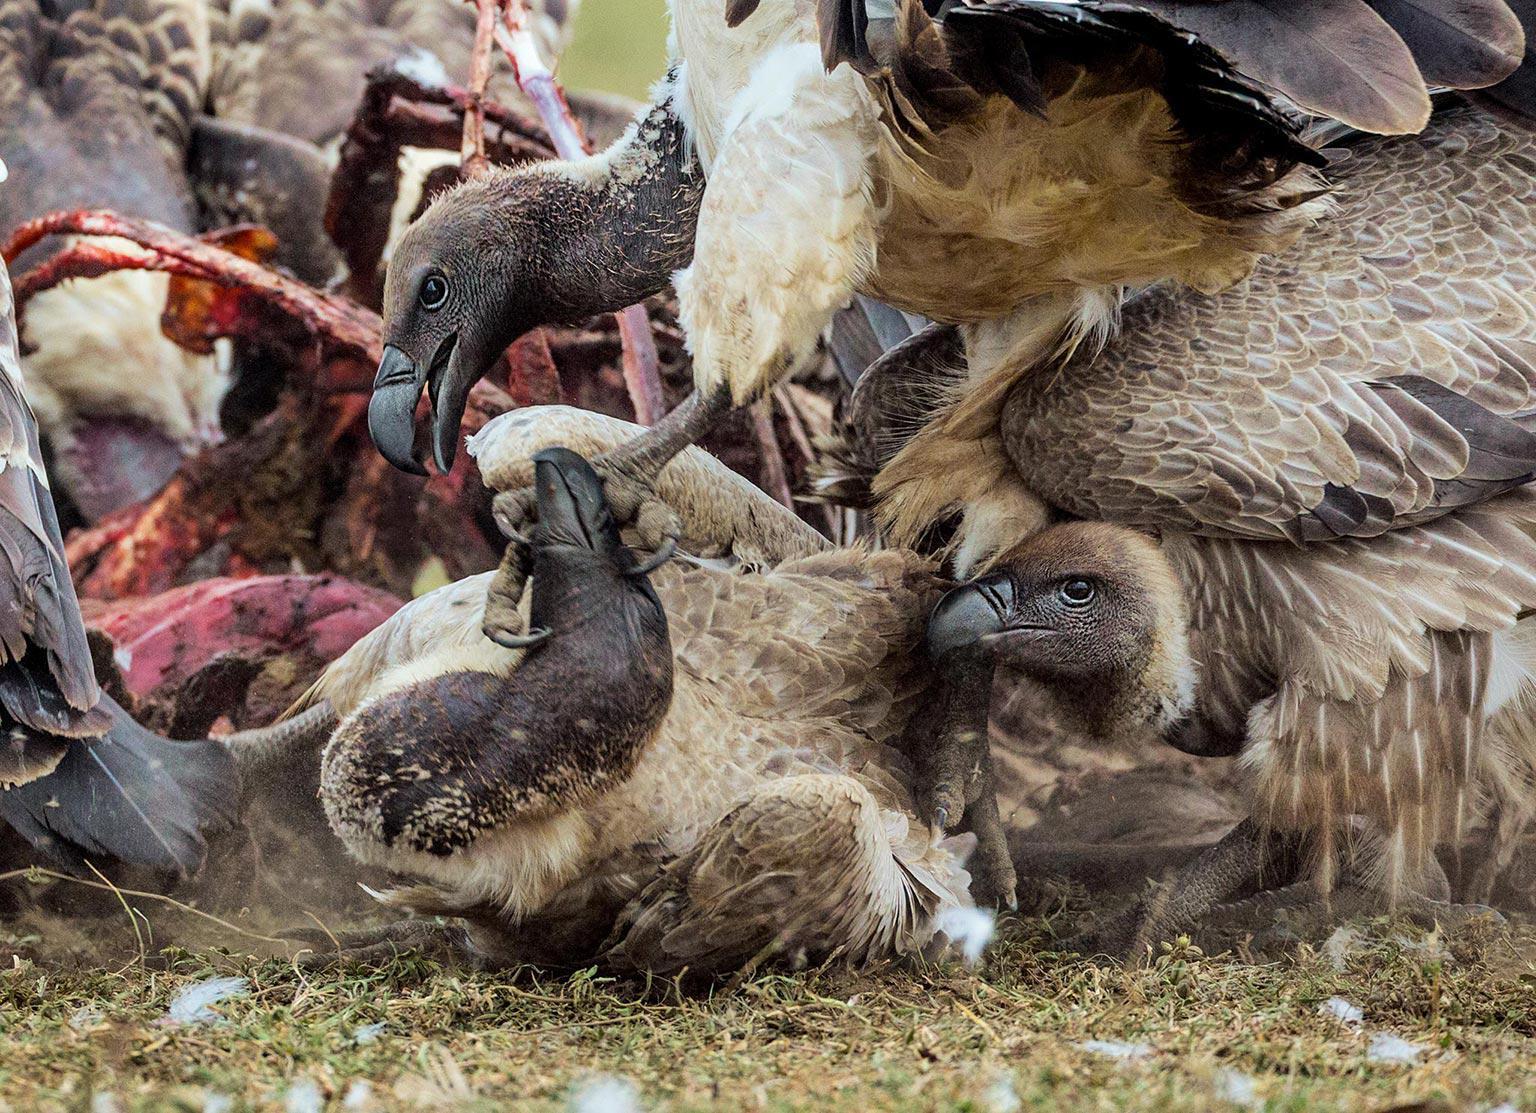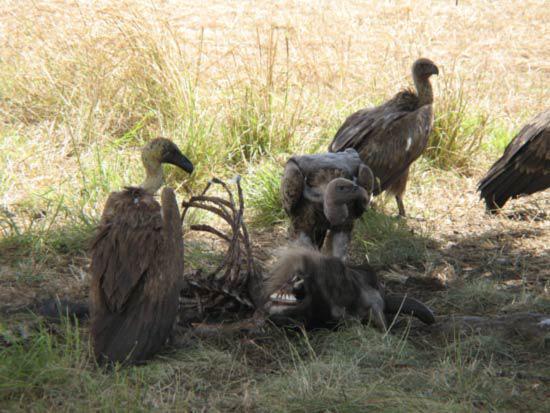The first image is the image on the left, the second image is the image on the right. For the images shown, is this caption "Vultures ripping flesh off of bones can be seen in one image." true? Answer yes or no. Yes. 